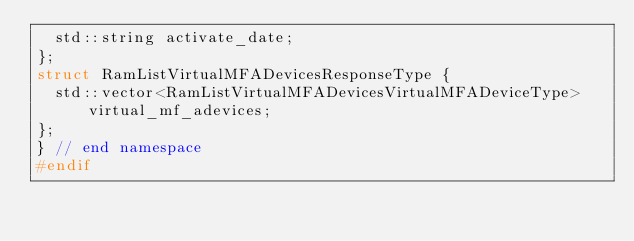Convert code to text. <code><loc_0><loc_0><loc_500><loc_500><_C_>  std::string activate_date;
};
struct RamListVirtualMFADevicesResponseType {
  std::vector<RamListVirtualMFADevicesVirtualMFADeviceType> virtual_mf_adevices;
};
} // end namespace
#endif
</code> 